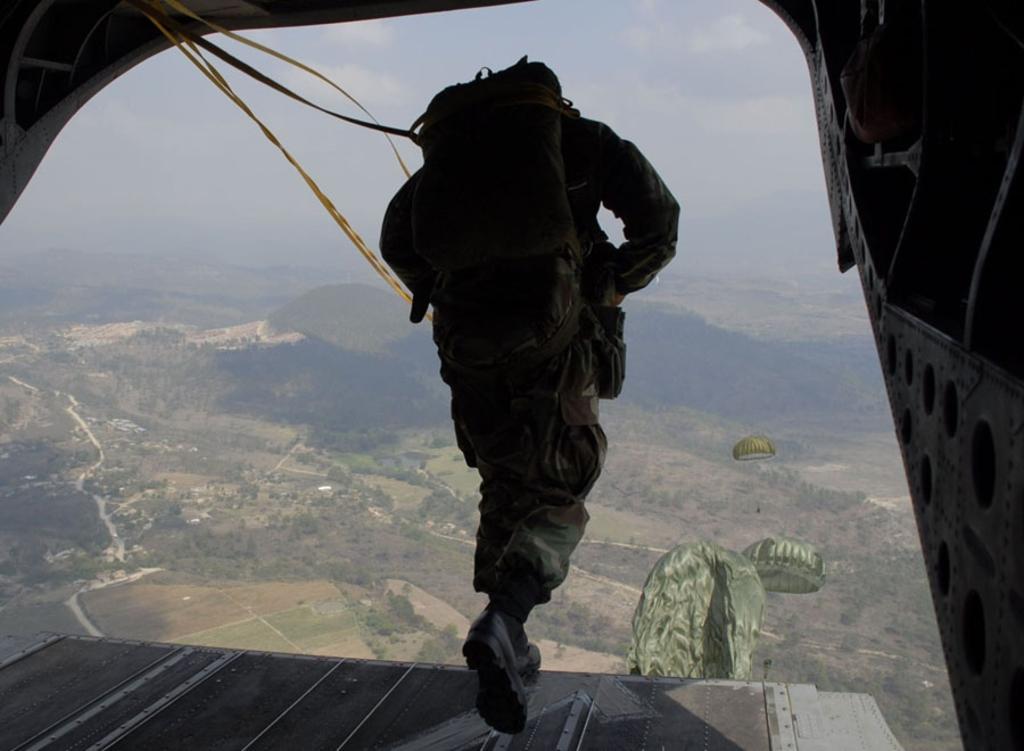How would you summarize this image in a sentence or two? In this picture there is a person wearing military dress is carrying a bag on his back and there are few parachutes in front of him and there are trees in the background. 